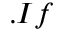Convert formula to latex. <formula><loc_0><loc_0><loc_500><loc_500>. I f</formula> 